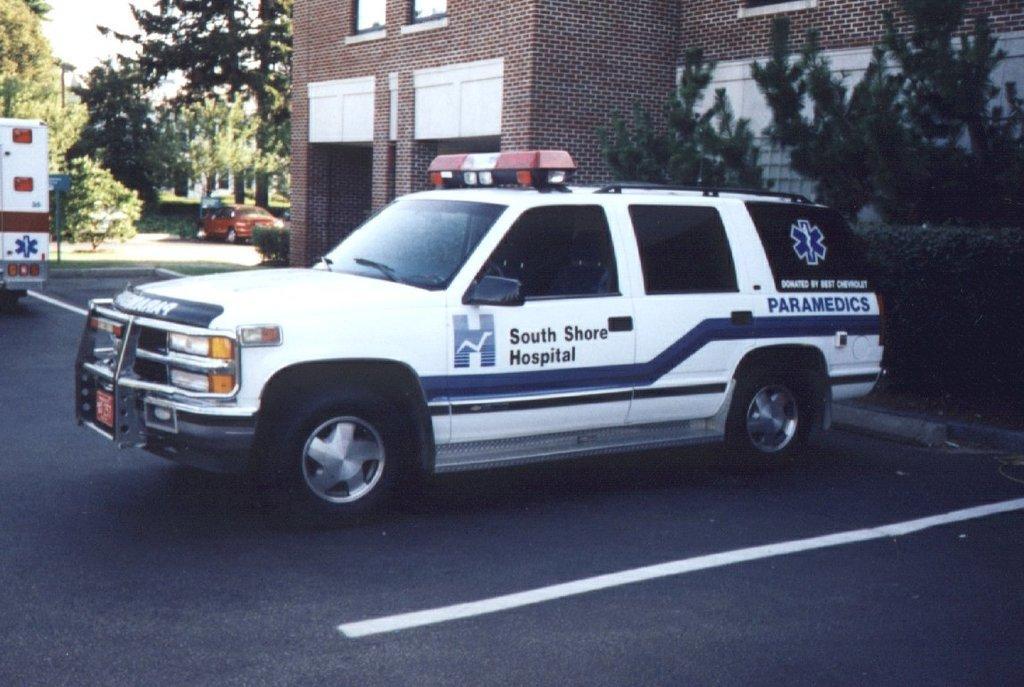Please provide a concise description of this image. There are some vehicles in the middle of this image and there are some trees and a building in the background. There is a road at the bottom of this image. 